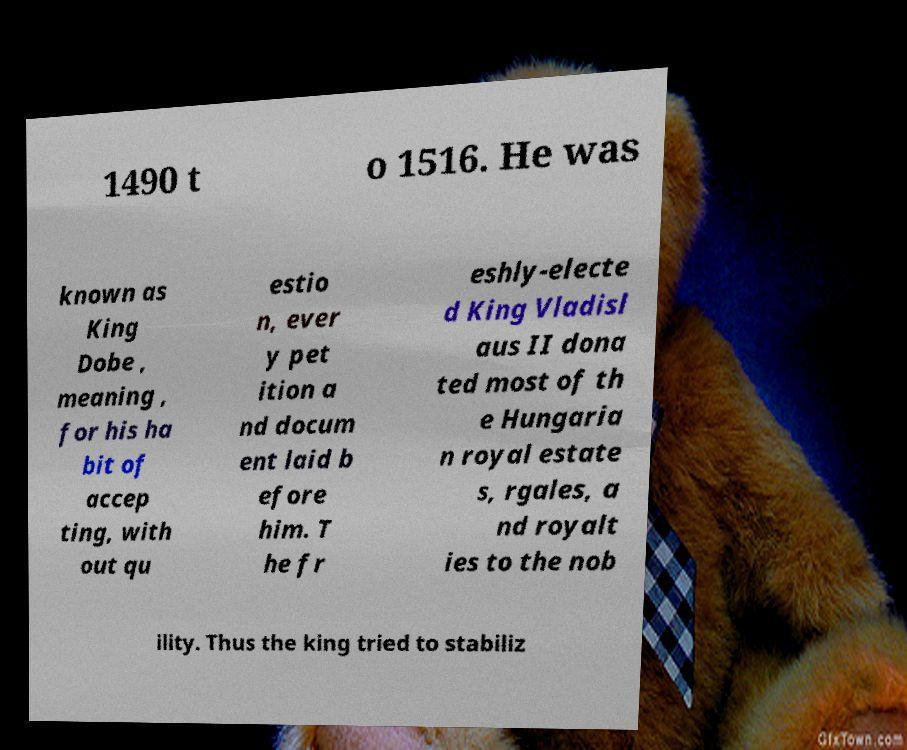Please identify and transcribe the text found in this image. 1490 t o 1516. He was known as King Dobe , meaning , for his ha bit of accep ting, with out qu estio n, ever y pet ition a nd docum ent laid b efore him. T he fr eshly-electe d King Vladisl aus II dona ted most of th e Hungaria n royal estate s, rgales, a nd royalt ies to the nob ility. Thus the king tried to stabiliz 